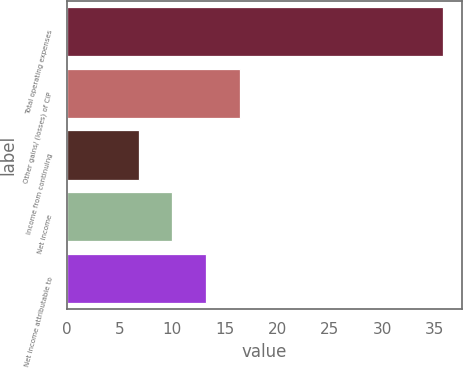<chart> <loc_0><loc_0><loc_500><loc_500><bar_chart><fcel>Total operating expenses<fcel>Other gains/ (losses) of CIP<fcel>Income from continuing<fcel>Net income<fcel>Net income attributable to<nl><fcel>35.8<fcel>16.48<fcel>6.82<fcel>10.04<fcel>13.26<nl></chart> 